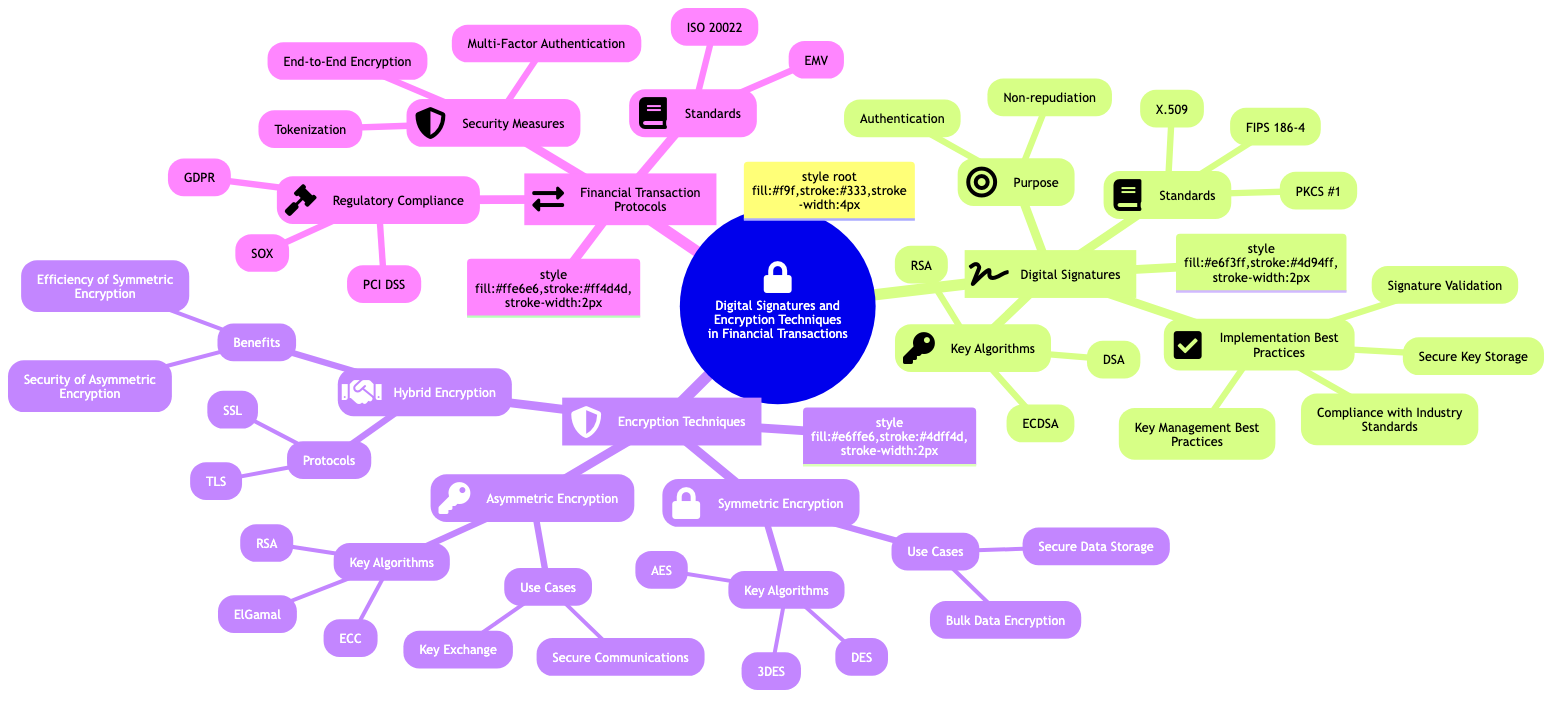What are the two purposes of Digital Signatures? The diagram lists "Authentication" and "Non-repudiation" under the "Purpose" node of Digital Signatures. These terms represent the two essential functions that digital signatures provide.
Answer: Authentication, Non-repudiation How many key algorithms are listed for Digital Signatures? The diagram shows three key algorithms for Digital Signatures: "RSA", "ECDSA", and "DSA". Thus, counting them gives us a total of three key algorithms.
Answer: 3 What is the benefit of Hybrid Encryption? The diagram provides two benefits of Hybrid Encryption: "Efficiency of Symmetric Encryption" and "Security of Asymmetric Encryption". These benefits summarize the key advantages of using Hybrid Encryption.
Answer: Efficiency of Symmetric Encryption, Security of Asymmetric Encryption Which encryption technique uses "Bulk Data Encryption"? The diagram categorizes "Bulk Data Encryption" under "Use Cases" for Symmetric Encryption. This implies that Symmetric Encryption is specifically used for this purpose.
Answer: Symmetric Encryption What is one regulatory compliance listed in the Financial Transaction Protocols? The diagram mentions several compliance standards under the "Regulatory Compliance" section of Financial Transaction Protocols. One example is "PCI DSS", which pertains to payment data security.
Answer: PCI DSS Name one standard for Financial Transaction Protocols. In the "Standards" section of Financial Transaction Protocols, "ISO 20022" is listed. This indicates that ISO 20022 is a recognized standard applicable in financial transactions.
Answer: ISO 20022 What is the number of key algorithms listed under Asymmetric Encryption? The diagram shows three key algorithms listed under the Asymmetric Encryption node: "RSA", "ECC", and "ElGamal". Counting these algorithms gives us three.
Answer: 3 Which encryption technique is described as having "Secure Communications" as a use case? The diagram lists "Secure Communications" under the Use Cases for Asymmetric Encryption. This shows that Asymmetric Encryption is used for secure communication channels.
Answer: Asymmetric Encryption What are the two security measures under Financial Transaction Protocols? The diagram mentions three security measures, of which "Multi-Factor Authentication" and "Tokenization" are two. Both measures are vital techniques used to enhance transaction security.
Answer: Multi-Factor Authentication, Tokenization 